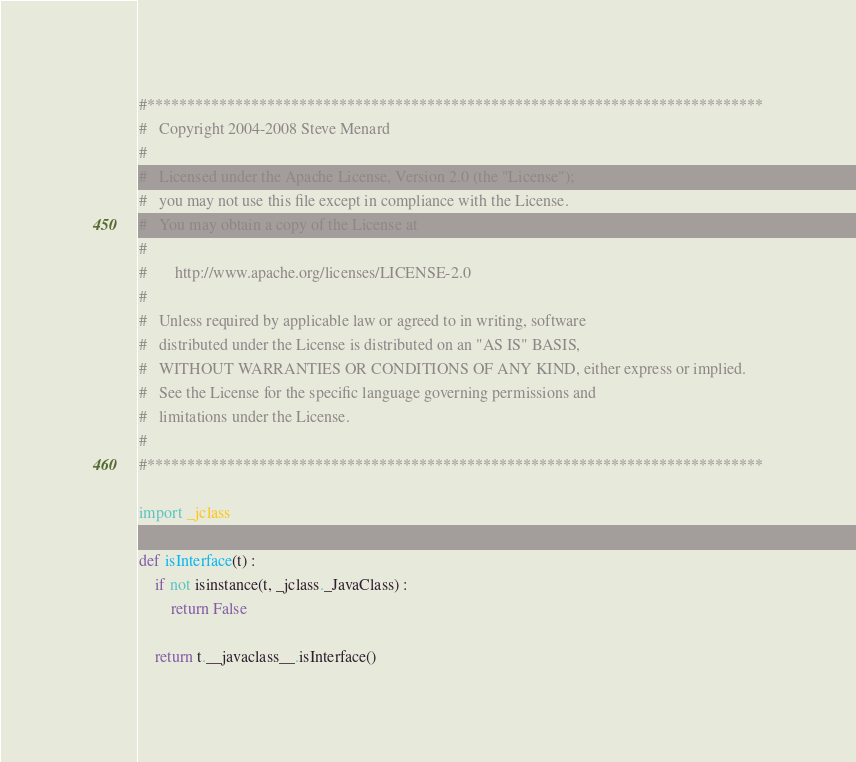Convert code to text. <code><loc_0><loc_0><loc_500><loc_500><_Python_>#*****************************************************************************
#   Copyright 2004-2008 Steve Menard
#
#   Licensed under the Apache License, Version 2.0 (the "License");
#   you may not use this file except in compliance with the License.
#   You may obtain a copy of the License at
#
#       http://www.apache.org/licenses/LICENSE-2.0
#
#   Unless required by applicable law or agreed to in writing, software
#   distributed under the License is distributed on an "AS IS" BASIS,
#   WITHOUT WARRANTIES OR CONDITIONS OF ANY KIND, either express or implied.
#   See the License for the specific language governing permissions and
#   limitations under the License.
#   
#*****************************************************************************

import _jclass

def isInterface(t) :
    if not isinstance(t, _jclass._JavaClass) :
        return False
        
    return t.__javaclass__.isInterface()
</code> 